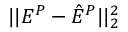<formula> <loc_0><loc_0><loc_500><loc_500>| | E ^ { P } - \hat { E } ^ { P } | | _ { 2 } ^ { 2 }</formula> 